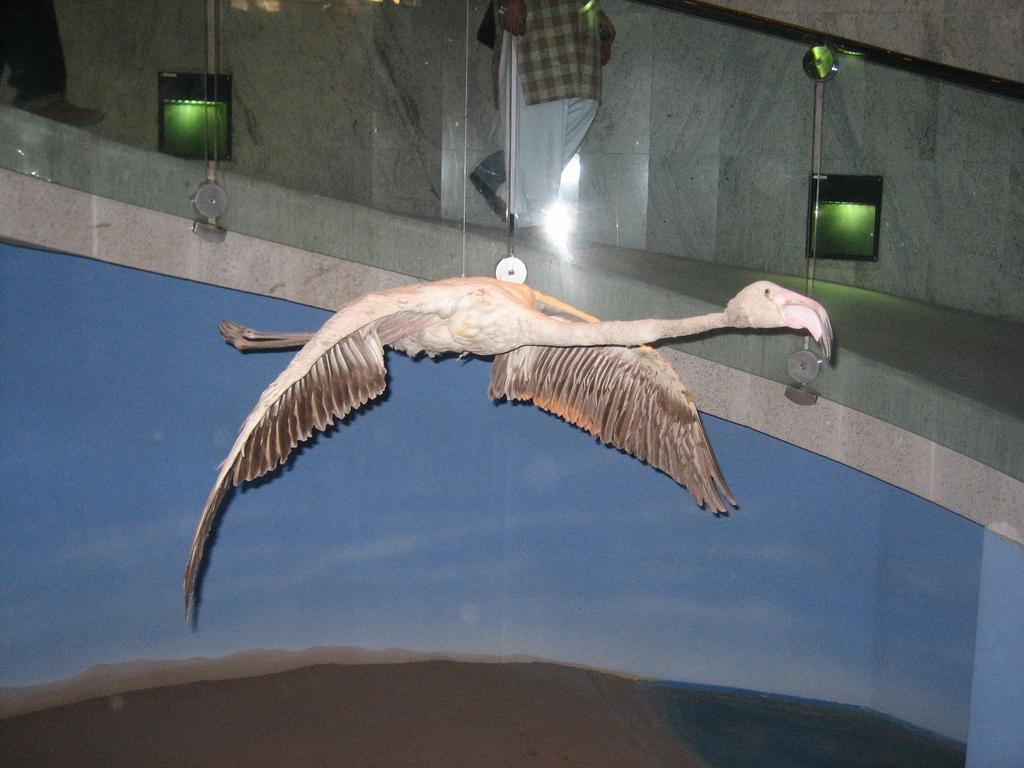Please provide a concise description of this image. In this image we can see an artificial bird is hang. In the background, we can see a wall, glass railing, lights and a person. 